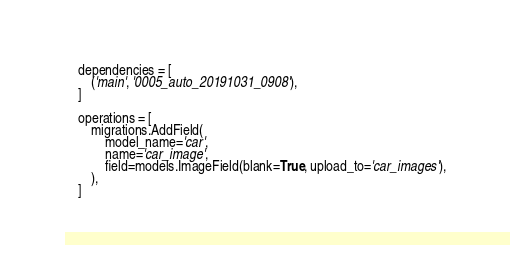Convert code to text. <code><loc_0><loc_0><loc_500><loc_500><_Python_>    dependencies = [
        ('main', '0005_auto_20191031_0908'),
    ]

    operations = [
        migrations.AddField(
            model_name='car',
            name='car_image',
            field=models.ImageField(blank=True, upload_to='car_images'),
        ),
    ]
</code> 